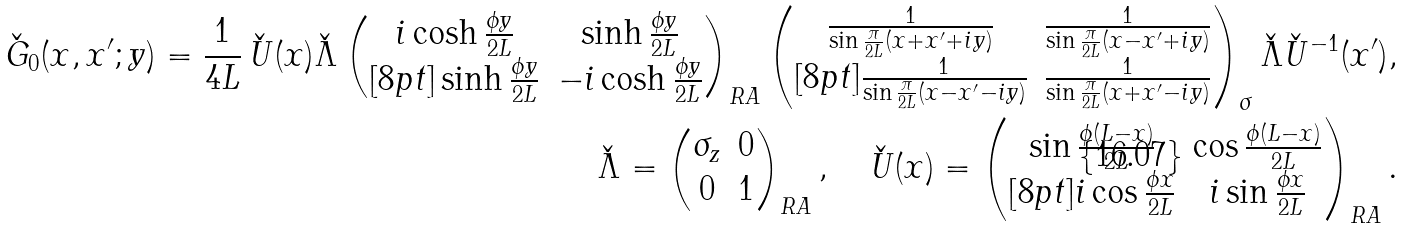<formula> <loc_0><loc_0><loc_500><loc_500>\check { G } _ { 0 } ( x , x ^ { \prime } ; y ) = \frac { 1 } { 4 L } \, \check { U } ( x ) \check { \Lambda } \begin{pmatrix} i \cosh \frac { \phi y } { 2 L } & \sinh \frac { \phi y } { 2 L } \\ [ 8 p t ] \sinh \frac { \phi y } { 2 L } & - i \cosh \frac { \phi y } { 2 L } \end{pmatrix} _ { R A } \begin{pmatrix} \frac { 1 } { \sin \frac { \pi } { 2 L } ( x + x ^ { \prime } + i y ) } & \frac { 1 } { \sin \frac { \pi } { 2 L } ( x - x ^ { \prime } + i y ) } \\ [ 8 p t ] \frac { 1 } { \sin \frac { \pi } { 2 L } ( x - x ^ { \prime } - i y ) } & \frac { 1 } { \sin \frac { \pi } { 2 L } ( x + x ^ { \prime } - i y ) } \end{pmatrix} _ { \sigma } \check { \Lambda } \check { U } ^ { - 1 } ( x ^ { \prime } ) , \\ \check { \Lambda } = \begin{pmatrix} \sigma _ { z } & 0 \\ 0 & 1 \end{pmatrix} _ { R A } , \quad \check { U } ( x ) = \begin{pmatrix} \sin \frac { \phi ( L - x ) } { 2 L } & \cos \frac { \phi ( L - x ) } { 2 L } \\ [ 8 p t ] i \cos \frac { \phi x } { 2 L } & i \sin \frac { \phi x } { 2 L } \end{pmatrix} _ { R A } .</formula> 